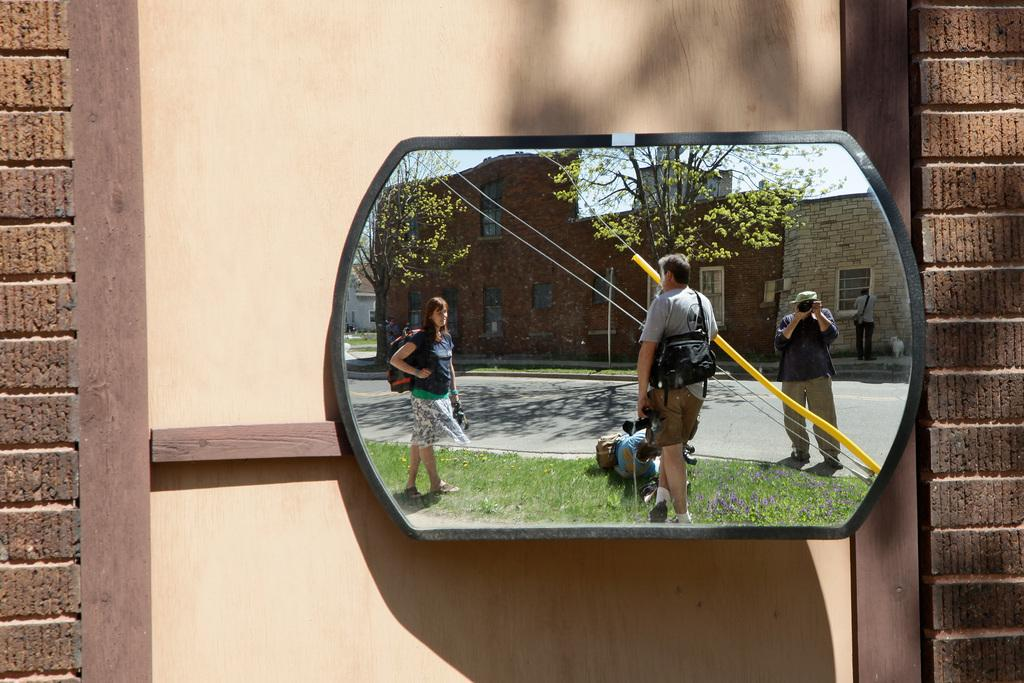What is the main object in the center of the image? There is a mirror in the center of the image. What types of animals can be seen at the zoo in the image? There is no zoo present in the image; it only features a mirror. What is the taste of the tomatoes in the image? There are no tomatoes present in the image, so their taste cannot be determined. 